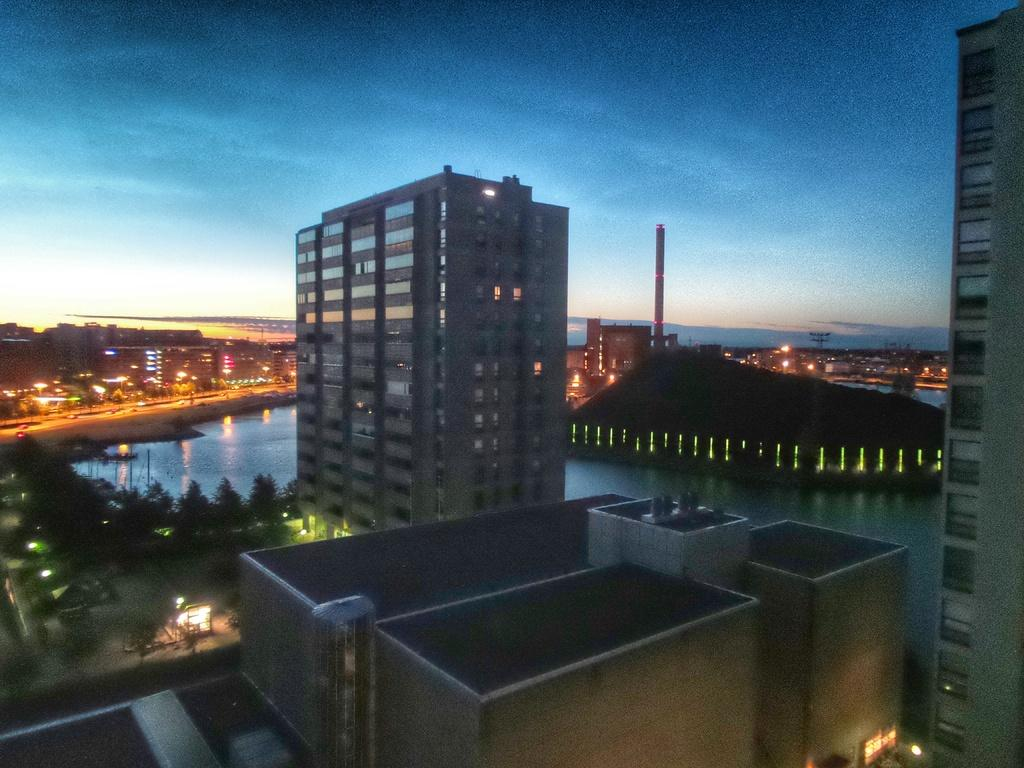What type of structures can be seen in the image? There are buildings in the image. What other natural elements are present in the image? There are trees in the image. What type of lighting is visible in the image? There are lights and street lights in the image. What body of water can be seen in the image? There is water visible in the image. Are there any other objects or features in the image? Yes, there are other objects in the image. What can be seen in the background of the image? The sky is visible in the background of the image. How many boys are pulling the street lights in the image? There are no boys present in the image, nor are any street lights being pulled. 